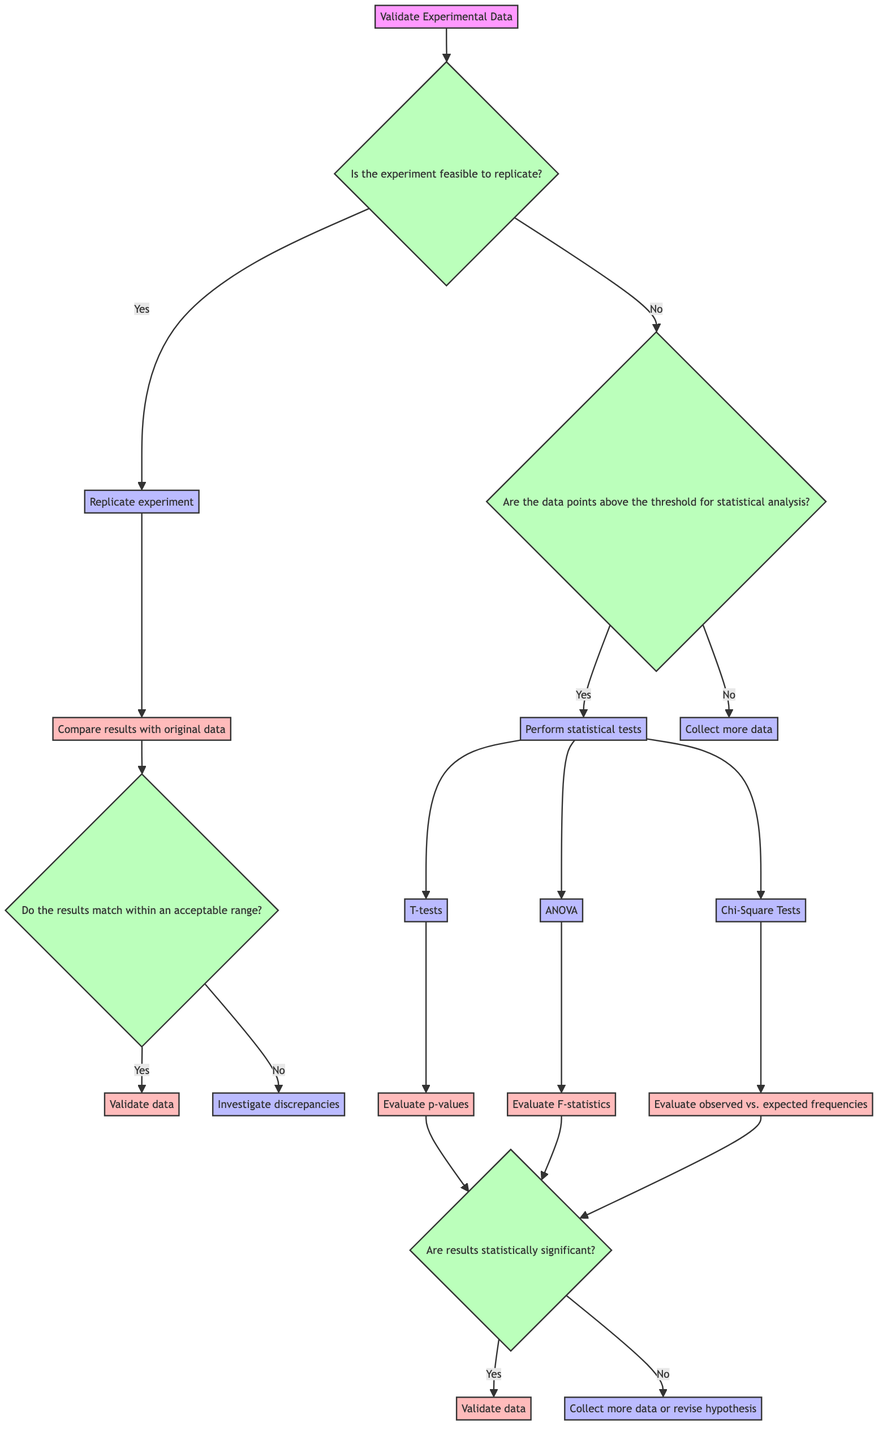What action is taken if the experiment is feasible to replicate? If the experiment is feasible to replicate, the action taken is to replicate the experiment. This is indicated by the "Yes" branch from the decision node regarding the feasibility of replication.
Answer: Replicate experiment What does the decision tree recommend if the results do not match within an acceptable range? If the results of the replicated experiment do not match within an acceptable range, the next step is to investigate discrepancies. This is depicted as the outcome from the decision about whether results match.
Answer: Investigate discrepancies How many methods of statistical tests are listed in the diagram? The diagram lists three methods of statistical tests: T-tests, ANOVA, and Chi-Square Tests. This can be counted directly from the methods outlined under the "Perform statistical tests" action.
Answer: Three What happens if the data points are not above the threshold for statistical analysis? If the data points are not above the threshold for statistical analysis, the next step is to collect more data. This is shown on the "No" branch from the condition about data points.
Answer: Collect more data What is the next step after evaluating p-values in the statistical analysis? After evaluating p-values in the statistical analysis, the next decision is to check if the results are statistically significant. This step follows the evaluation of the test results.
Answer: Are results statistically significant? What is the outcome if the results from statistical tests are statistically significant? If the results from the statistical tests are statistically significant, the data is validated. This is shown as the outcome from the decision regarding statistical significance of results.
Answer: Validate data What should be done if the results of the replicated experiment match? If the results of the replicated experiment match within an acceptable range, the data is validated. This is indicated in the decision tree as a direct outcome from matching results.
Answer: Validate data What is the first decision point in this decision tree? The first decision point in this decision tree is to validate experimental data, which is the overarching decision at the root of the tree.
Answer: Validate Experimental Data 